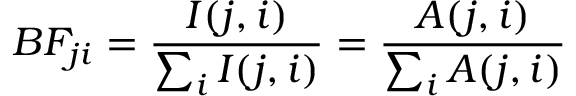Convert formula to latex. <formula><loc_0><loc_0><loc_500><loc_500>B F _ { j i } = \frac { I ( j , i ) } { \sum _ { i } I ( j , i ) } = \frac { A ( j , i ) } { \sum _ { i } A ( j , i ) }</formula> 